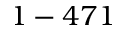<formula> <loc_0><loc_0><loc_500><loc_500>1 - 4 7 1</formula> 